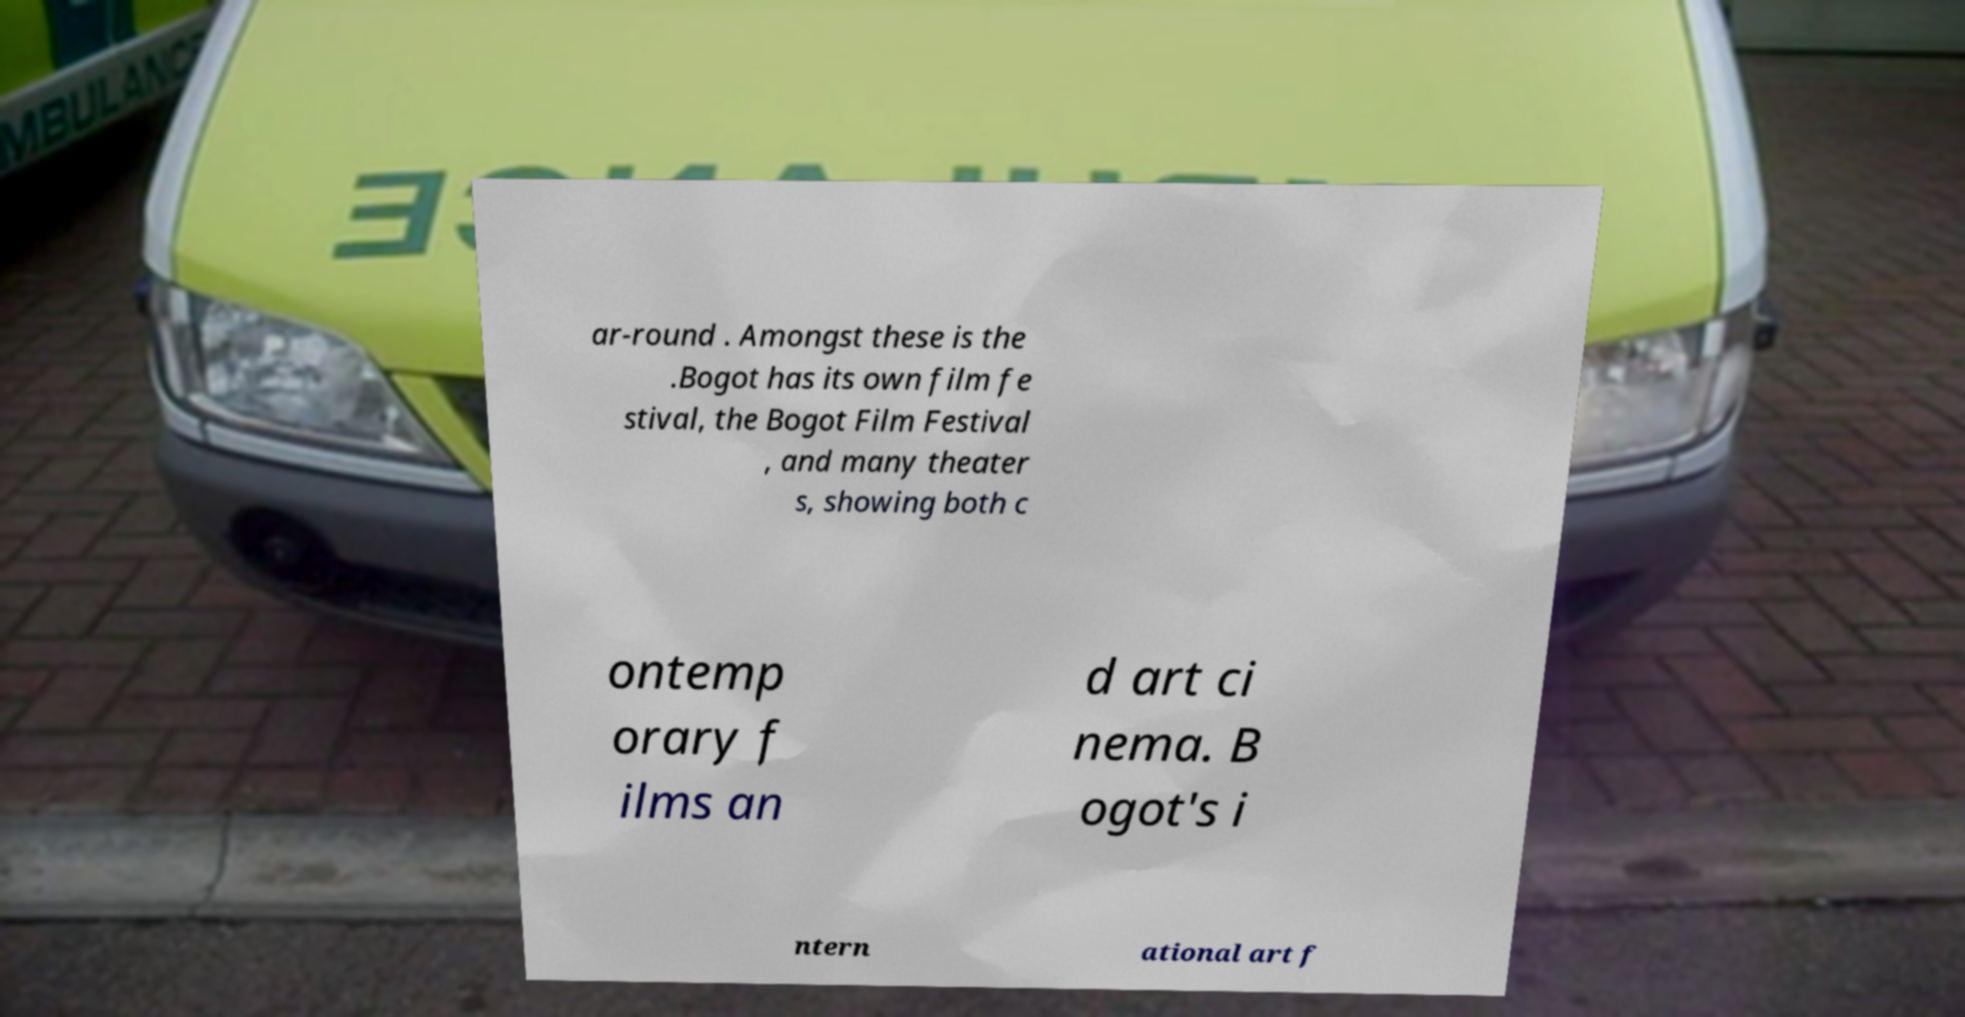Please read and relay the text visible in this image. What does it say? ar-round . Amongst these is the .Bogot has its own film fe stival, the Bogot Film Festival , and many theater s, showing both c ontemp orary f ilms an d art ci nema. B ogot's i ntern ational art f 